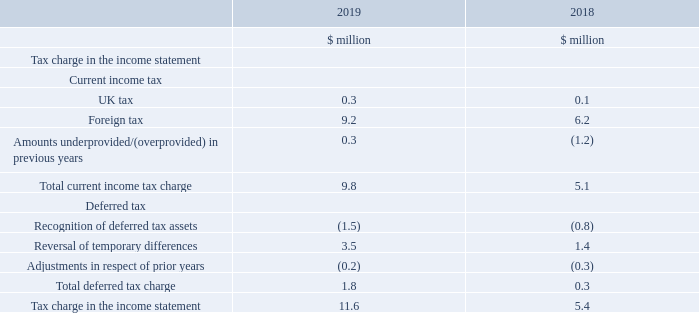10. Tax
The tax charge for the year ended 31 December 2019 was $11.6 million (2018 $5.4 million). This was after a prior year tax charge of $0.1 million and a tax credit on the adjusting items of $0.7 million (2018 prior year credit of $1.5 million and tax credit on adjusting items of $5.2 million). Excluding the prior year and tax credit on adjusting items, the effective tax rate was 13.0 per cent (2018 15.4 per cent).
What was the tax charge for the year ended 31 December 2019? $11.6 million. What was the effective tax rate excluding the prior year and tax credit on adjusting items? 13.0 per cent. Which are the broad categories of tax considered in the tax charge in the income statement? Current income tax, deferred tax. In which year was the UK tax larger? 0.3>0.1
Answer: 2019. What was the change in the tax charge in the income statement?
Answer scale should be: million. 11.6-5.4
Answer: 6.2. What was the percentage change in the tax charge in the income statement?
Answer scale should be: percent. (11.6-5.4)/5.4
Answer: 114.81. 